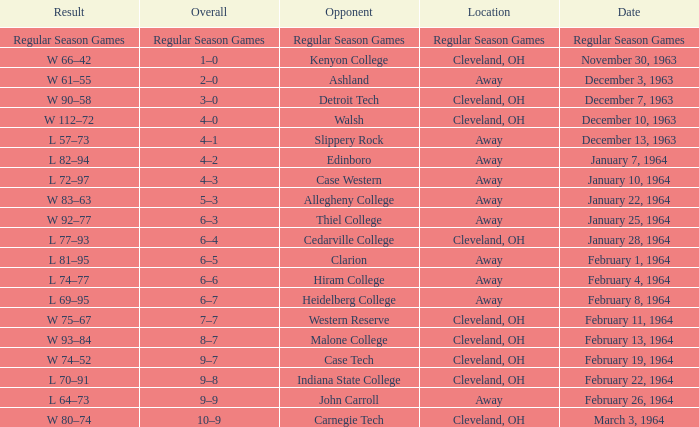Can you give me this table as a dict? {'header': ['Result', 'Overall', 'Opponent', 'Location', 'Date'], 'rows': [['Regular Season Games', 'Regular Season Games', 'Regular Season Games', 'Regular Season Games', 'Regular Season Games'], ['W 66–42', '1–0', 'Kenyon College', 'Cleveland, OH', 'November 30, 1963'], ['W 61–55', '2–0', 'Ashland', 'Away', 'December 3, 1963'], ['W 90–58', '3–0', 'Detroit Tech', 'Cleveland, OH', 'December 7, 1963'], ['W 112–72', '4–0', 'Walsh', 'Cleveland, OH', 'December 10, 1963'], ['L 57–73', '4–1', 'Slippery Rock', 'Away', 'December 13, 1963'], ['L 82–94', '4–2', 'Edinboro', 'Away', 'January 7, 1964'], ['L 72–97', '4–3', 'Case Western', 'Away', 'January 10, 1964'], ['W 83–63', '5–3', 'Allegheny College', 'Away', 'January 22, 1964'], ['W 92–77', '6–3', 'Thiel College', 'Away', 'January 25, 1964'], ['L 77–93', '6–4', 'Cedarville College', 'Cleveland, OH', 'January 28, 1964'], ['L 81–95', '6–5', 'Clarion', 'Away', 'February 1, 1964'], ['L 74–77', '6–6', 'Hiram College', 'Away', 'February 4, 1964'], ['L 69–95', '6–7', 'Heidelberg College', 'Away', 'February 8, 1964'], ['W 75–67', '7–7', 'Western Reserve', 'Cleveland, OH', 'February 11, 1964'], ['W 93–84', '8–7', 'Malone College', 'Cleveland, OH', 'February 13, 1964'], ['W 74–52', '9–7', 'Case Tech', 'Cleveland, OH', 'February 19, 1964'], ['L 70–91', '9–8', 'Indiana State College', 'Cleveland, OH', 'February 22, 1964'], ['L 64–73', '9–9', 'John Carroll', 'Away', 'February 26, 1964'], ['W 80–74', '10–9', 'Carnegie Tech', 'Cleveland, OH', 'March 3, 1964']]} What is the Location with a Date that is december 10, 1963? Cleveland, OH. 